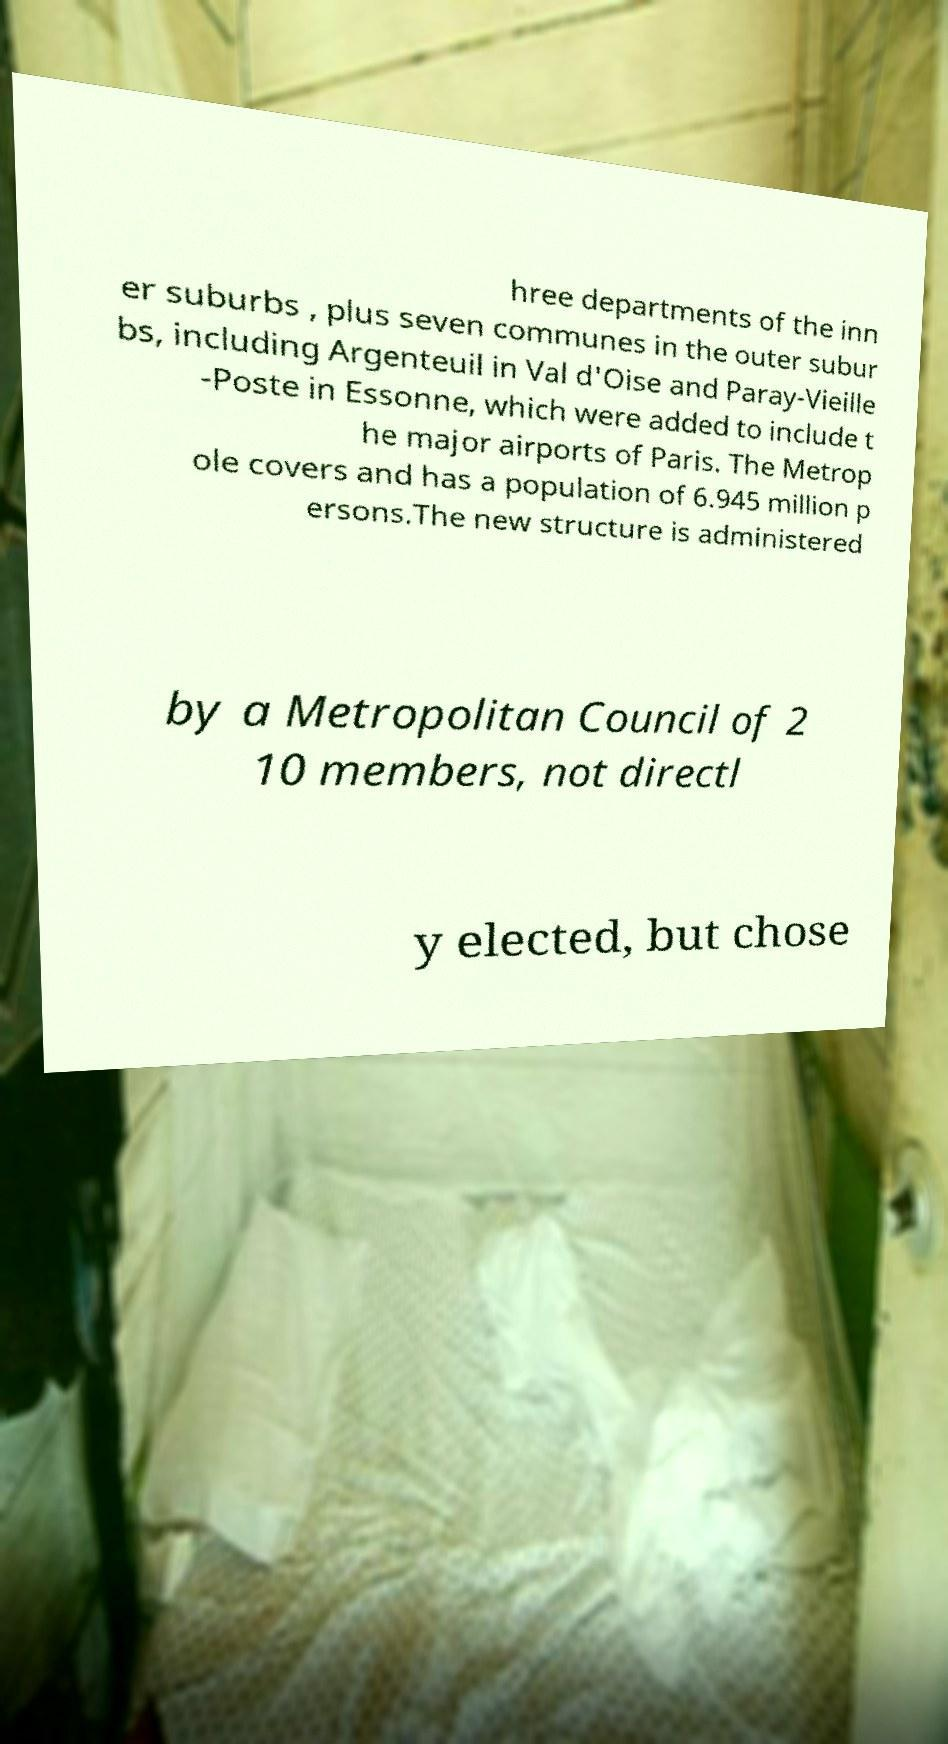Please read and relay the text visible in this image. What does it say? hree departments of the inn er suburbs , plus seven communes in the outer subur bs, including Argenteuil in Val d'Oise and Paray-Vieille -Poste in Essonne, which were added to include t he major airports of Paris. The Metrop ole covers and has a population of 6.945 million p ersons.The new structure is administered by a Metropolitan Council of 2 10 members, not directl y elected, but chose 